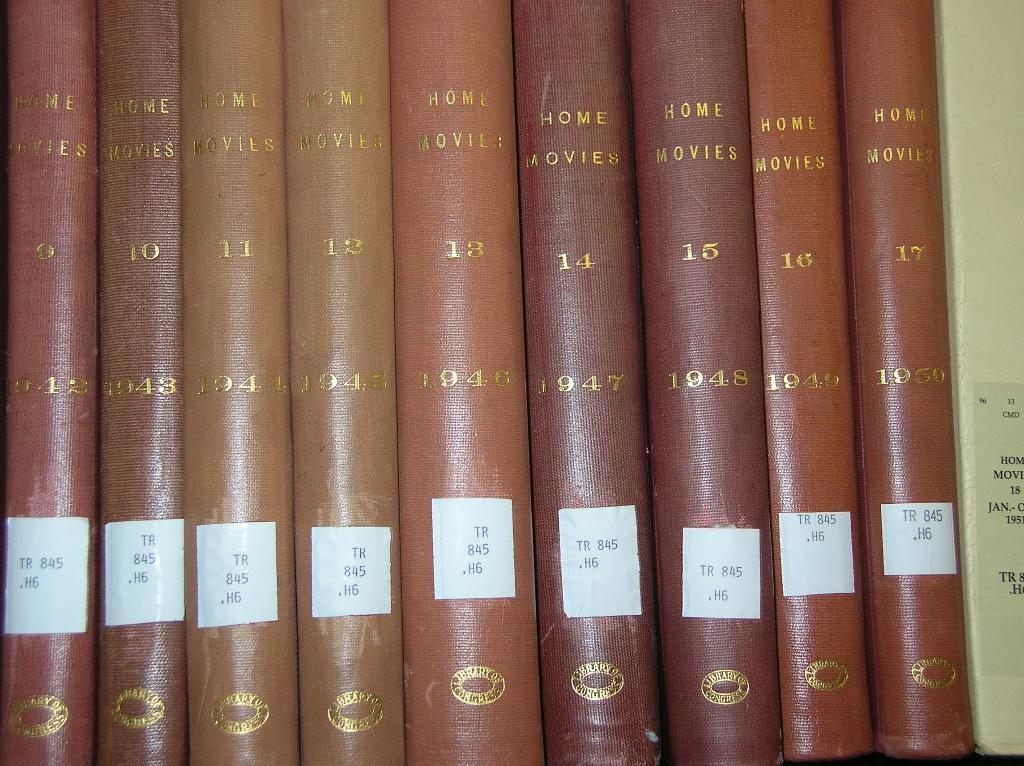<image>
Render a clear and concise summary of the photo. The spines of nine video tape cases are seen vertically and are a series of old home movies. 